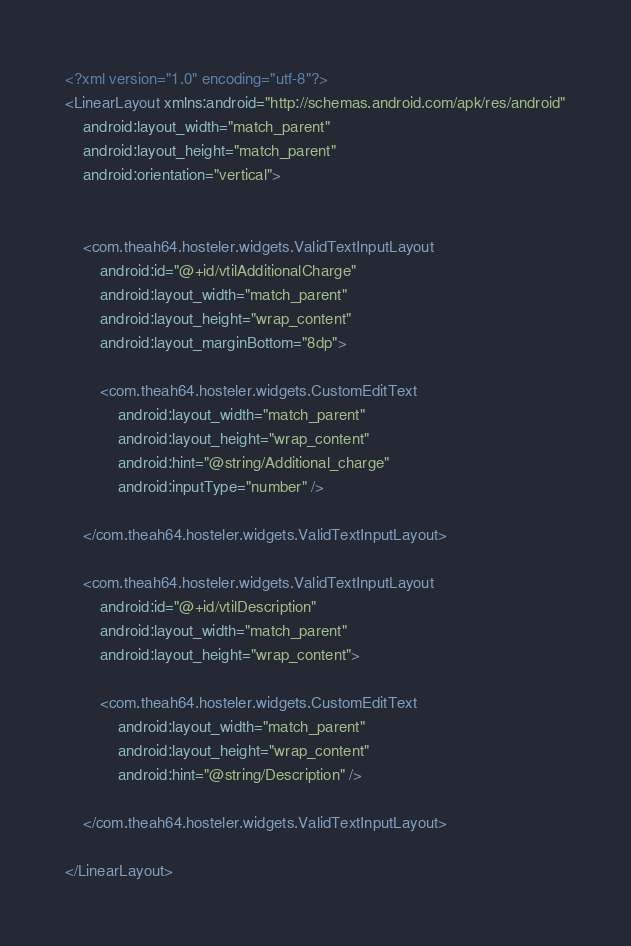<code> <loc_0><loc_0><loc_500><loc_500><_XML_><?xml version="1.0" encoding="utf-8"?>
<LinearLayout xmlns:android="http://schemas.android.com/apk/res/android"
    android:layout_width="match_parent"
    android:layout_height="match_parent"
    android:orientation="vertical">


    <com.theah64.hosteler.widgets.ValidTextInputLayout
        android:id="@+id/vtilAdditionalCharge"
        android:layout_width="match_parent"
        android:layout_height="wrap_content"
        android:layout_marginBottom="8dp">

        <com.theah64.hosteler.widgets.CustomEditText
            android:layout_width="match_parent"
            android:layout_height="wrap_content"
            android:hint="@string/Additional_charge"
            android:inputType="number" />

    </com.theah64.hosteler.widgets.ValidTextInputLayout>

    <com.theah64.hosteler.widgets.ValidTextInputLayout
        android:id="@+id/vtilDescription"
        android:layout_width="match_parent"
        android:layout_height="wrap_content">

        <com.theah64.hosteler.widgets.CustomEditText
            android:layout_width="match_parent"
            android:layout_height="wrap_content"
            android:hint="@string/Description" />

    </com.theah64.hosteler.widgets.ValidTextInputLayout>

</LinearLayout></code> 